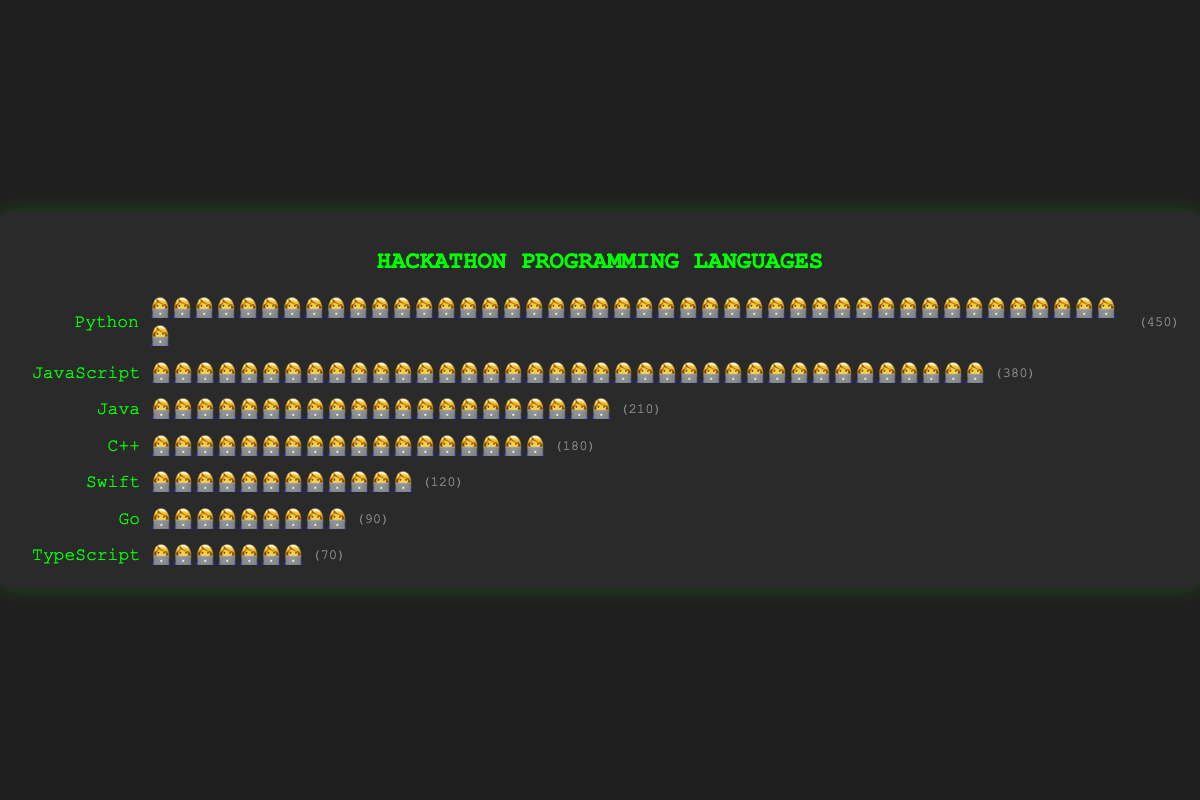What's the title of the figure? The title is located at the top of the figure.
Answer: Hackathon Programming Languages What symbol is used to represent participants? The symbol can be seen repeatedly across rows.
Answer: 👩‍💻 Which language has the highest number of participants? Count the number of symbols in each row; the longest row represents the most popular language. Python's row is the longest.
Answer: Python Which language has the least number of participants? Count the number of symbols in each row; the shortest row represents the least popular language. TypeScript's row is the shortest.
Answer: TypeScript How many participants does Java have? By counting the symbols next to Java and using the "symbolValue" of 10 provided in the data, we multiply by 10. There are 21 symbols for Java.
Answer: 210 How many more participants does Python have compared to JavaScript? Find the difference between the number of participants for Python and JavaScript. Python has 450 participants, and JavaScript has 380. The difference is 450 - 380 = 70.
Answer: 70 What is the total number of participants represented in the figure? Sum the number of participants for all the languages: 450 + 380 + 210 + 180 + 120 + 90 + 70. Calculate the total.
Answer: 1500 How many more participants use Python than Swift? Subtract Swift's participants from Python's participants: 450 - 120.
Answer: 330 Which languages have more than 100 participants? Check each language's participant count: Python (450), JavaScript (380), Java (210), C++ (180), and Swift (120) all have more than 100 participants.
Answer: Python, JavaScript, Java, C++, Swift What percentage of participants use Go? Calculate the percentage by dividing Go's participants by the total number of participants then multiply by 100: (90 / 1500) * 100.
Answer: 6% 